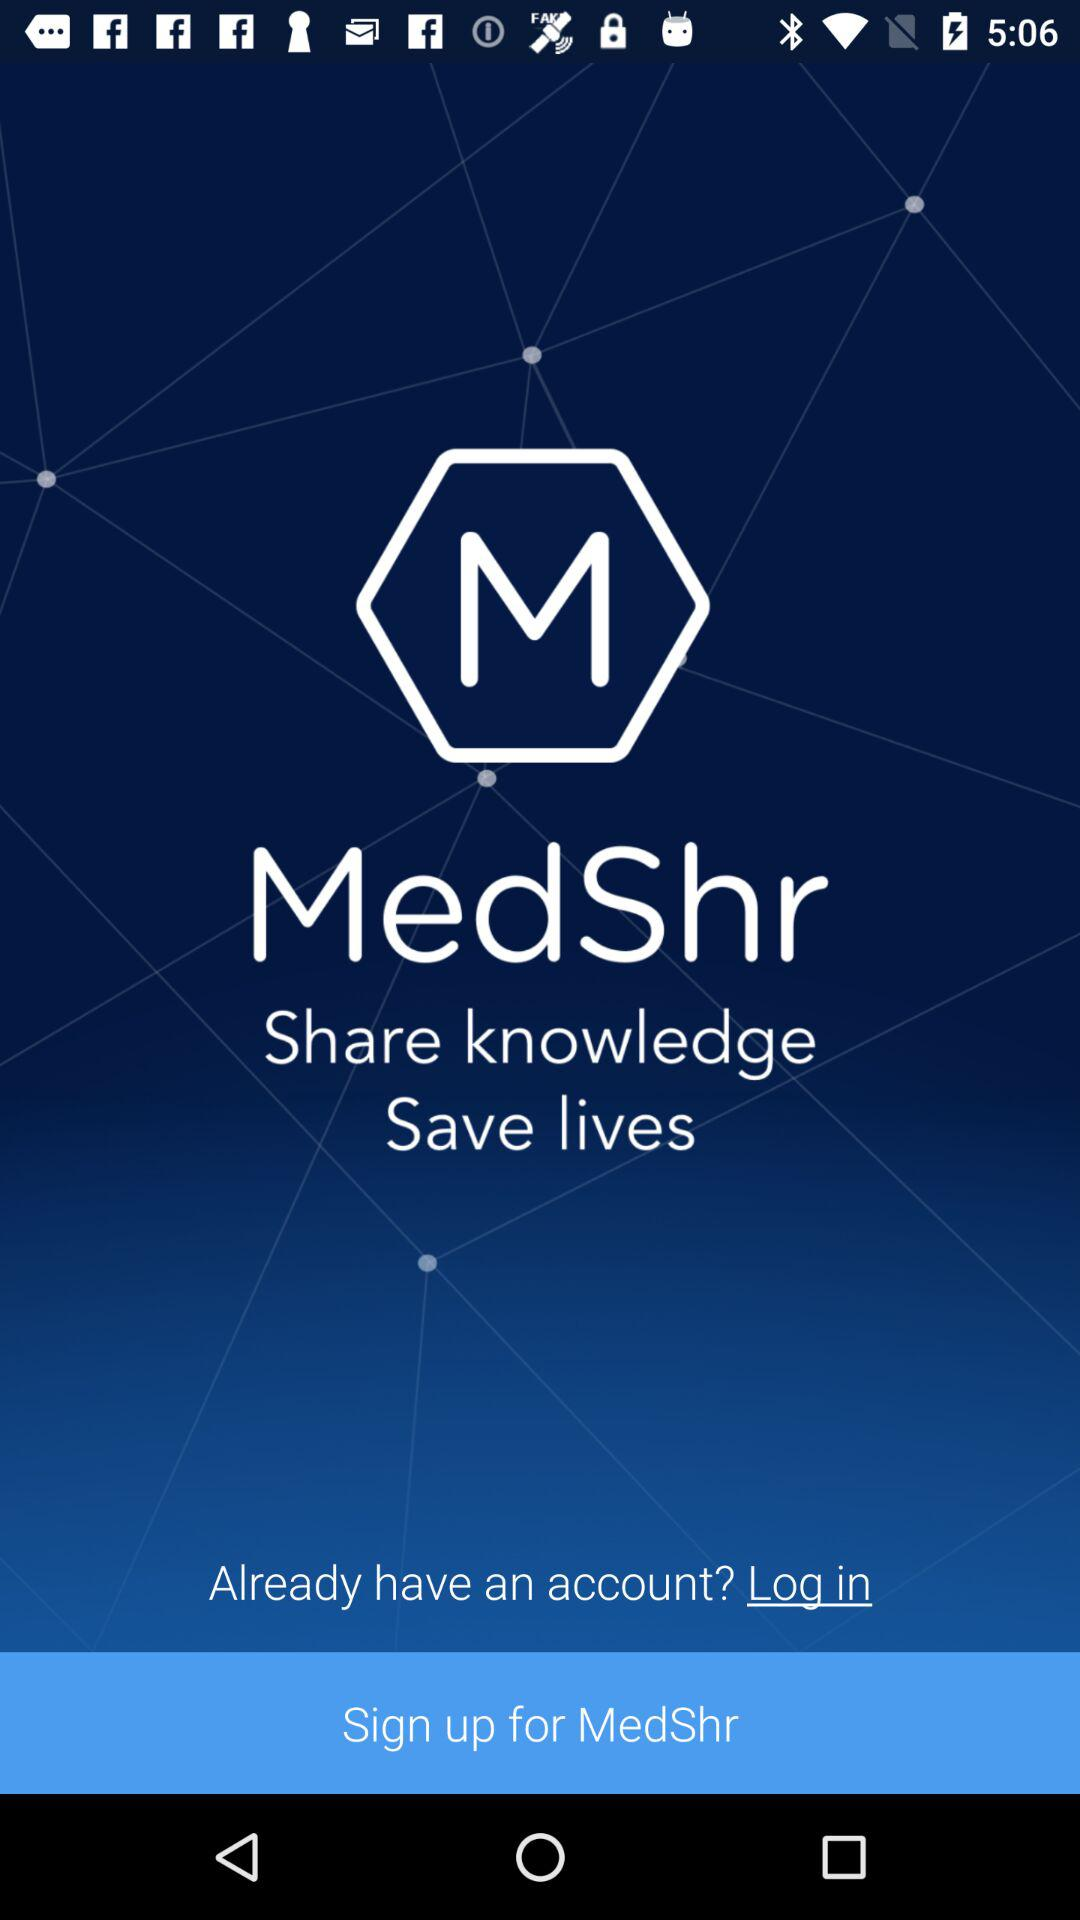What is the application name? The application name is "MedShr". 